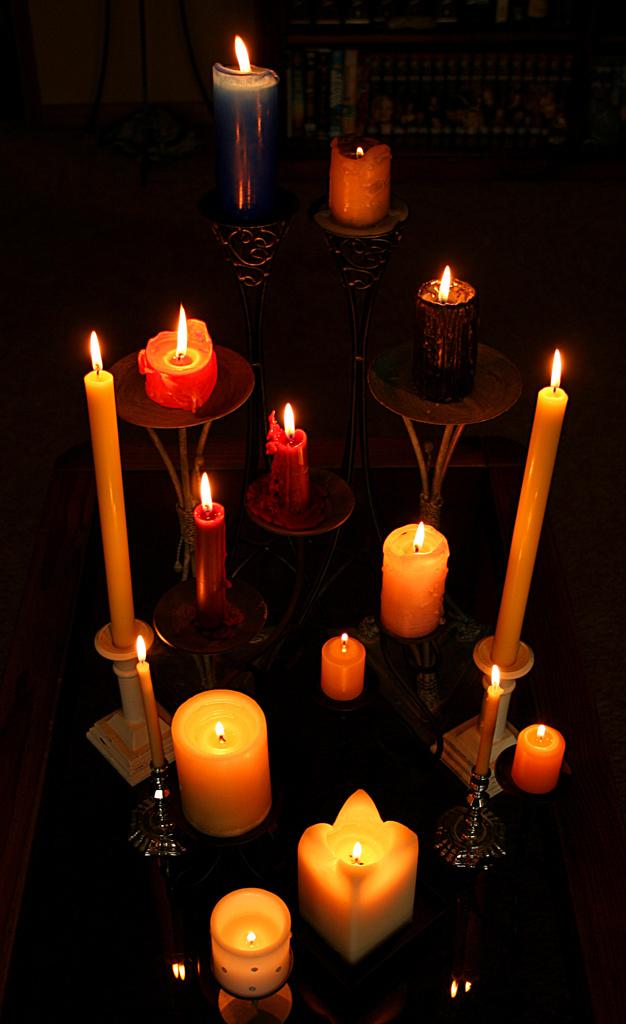What objects are in the foreground of the image? There are candles in the foreground of the image. Are the candles arranged in any specific way? Some of the candles are on a candle holder. On what surface are the candles placed? The candles are on a surface. Who is the expert on the pie in the image? There is no pie present in the image, so there is no expert on a pie. 